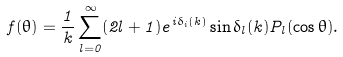<formula> <loc_0><loc_0><loc_500><loc_500>f ( \theta ) = \frac { 1 } { k } \sum _ { l = 0 } ^ { \infty } ( 2 l + 1 ) e ^ { i \delta _ { i } ( k ) } \sin \delta _ { l } ( k ) P _ { l } ( \cos \theta ) .</formula> 